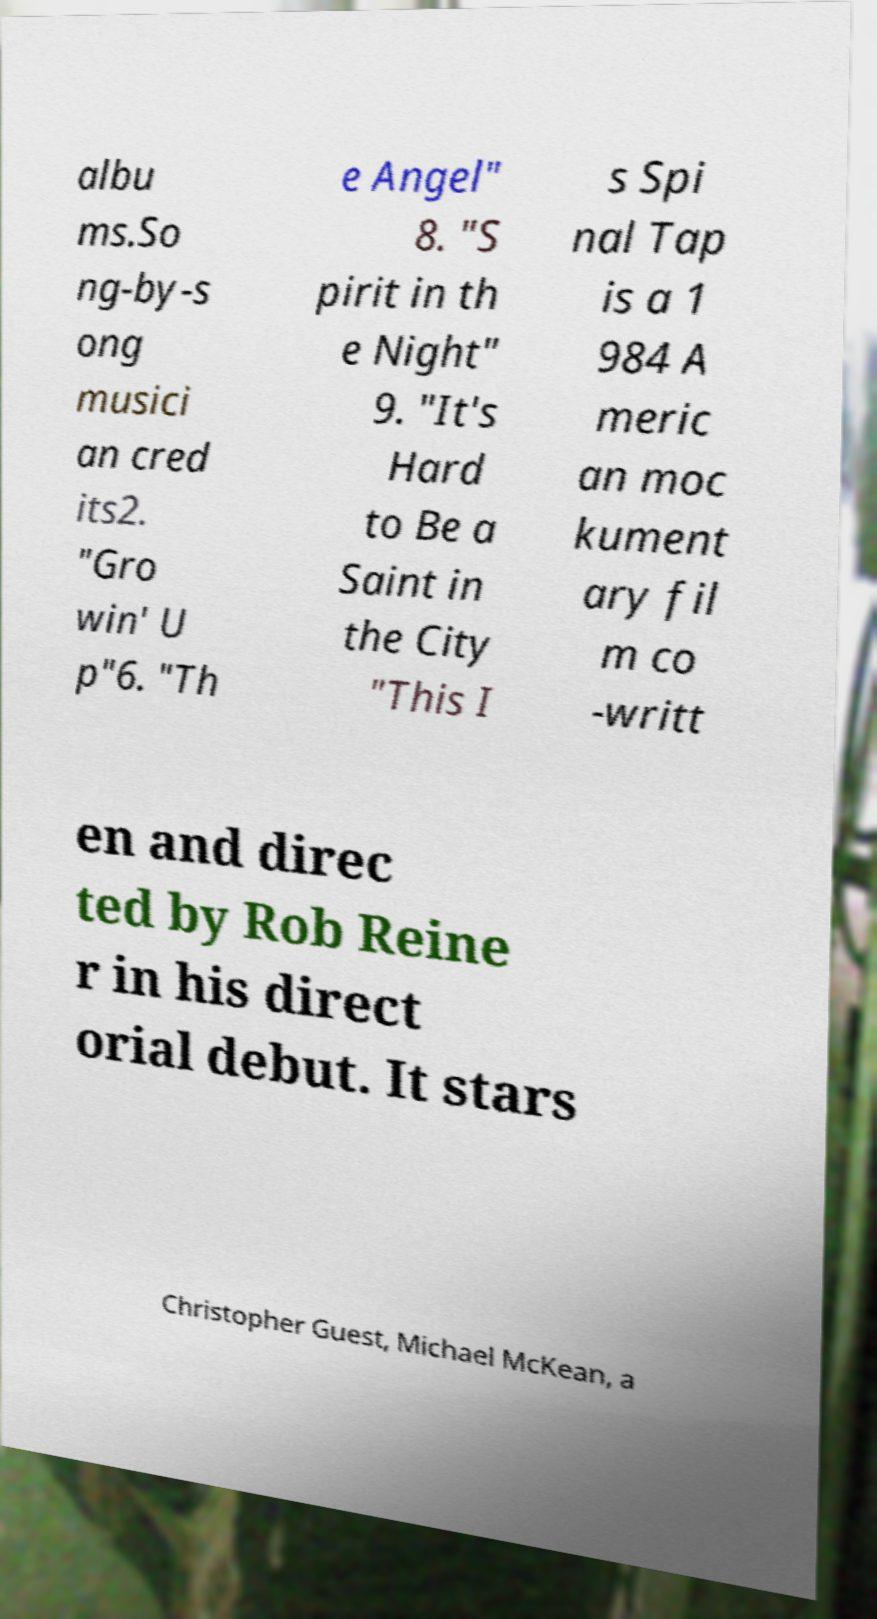Could you extract and type out the text from this image? albu ms.So ng-by-s ong musici an cred its2. "Gro win' U p"6. "Th e Angel" 8. "S pirit in th e Night" 9. "It's Hard to Be a Saint in the City "This I s Spi nal Tap is a 1 984 A meric an moc kument ary fil m co -writt en and direc ted by Rob Reine r in his direct orial debut. It stars Christopher Guest, Michael McKean, a 